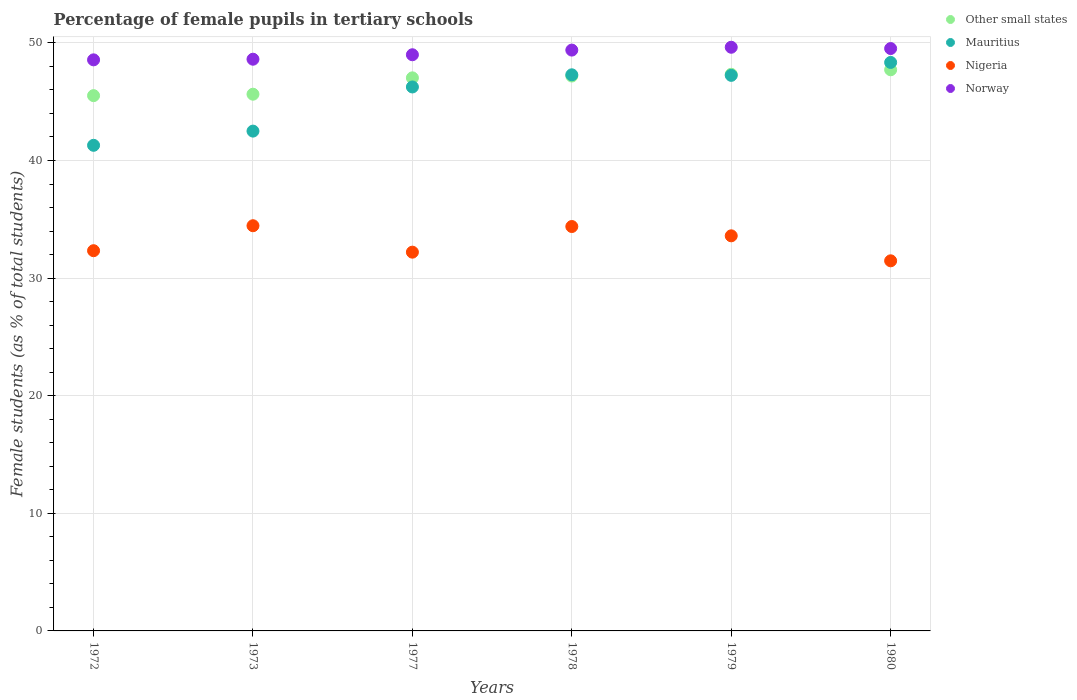What is the percentage of female pupils in tertiary schools in Other small states in 1973?
Make the answer very short. 45.64. Across all years, what is the maximum percentage of female pupils in tertiary schools in Other small states?
Your response must be concise. 47.71. Across all years, what is the minimum percentage of female pupils in tertiary schools in Other small states?
Your answer should be very brief. 45.52. In which year was the percentage of female pupils in tertiary schools in Norway minimum?
Give a very brief answer. 1972. What is the total percentage of female pupils in tertiary schools in Norway in the graph?
Offer a terse response. 294.7. What is the difference between the percentage of female pupils in tertiary schools in Norway in 1977 and that in 1979?
Your response must be concise. -0.64. What is the difference between the percentage of female pupils in tertiary schools in Mauritius in 1973 and the percentage of female pupils in tertiary schools in Other small states in 1980?
Your answer should be very brief. -5.22. What is the average percentage of female pupils in tertiary schools in Mauritius per year?
Your answer should be compact. 45.48. In the year 1972, what is the difference between the percentage of female pupils in tertiary schools in Other small states and percentage of female pupils in tertiary schools in Nigeria?
Make the answer very short. 13.19. What is the ratio of the percentage of female pupils in tertiary schools in Norway in 1973 to that in 1977?
Your response must be concise. 0.99. Is the percentage of female pupils in tertiary schools in Nigeria in 1977 less than that in 1978?
Offer a very short reply. Yes. Is the difference between the percentage of female pupils in tertiary schools in Other small states in 1973 and 1980 greater than the difference between the percentage of female pupils in tertiary schools in Nigeria in 1973 and 1980?
Your answer should be compact. No. What is the difference between the highest and the second highest percentage of female pupils in tertiary schools in Mauritius?
Your answer should be very brief. 1.05. What is the difference between the highest and the lowest percentage of female pupils in tertiary schools in Other small states?
Ensure brevity in your answer.  2.2. Is the sum of the percentage of female pupils in tertiary schools in Norway in 1972 and 1980 greater than the maximum percentage of female pupils in tertiary schools in Nigeria across all years?
Your answer should be compact. Yes. Does the percentage of female pupils in tertiary schools in Norway monotonically increase over the years?
Provide a succinct answer. No. How many years are there in the graph?
Your response must be concise. 6. Are the values on the major ticks of Y-axis written in scientific E-notation?
Keep it short and to the point. No. Does the graph contain any zero values?
Provide a succinct answer. No. Where does the legend appear in the graph?
Provide a succinct answer. Top right. How many legend labels are there?
Offer a very short reply. 4. What is the title of the graph?
Offer a terse response. Percentage of female pupils in tertiary schools. What is the label or title of the Y-axis?
Give a very brief answer. Female students (as % of total students). What is the Female students (as % of total students) of Other small states in 1972?
Give a very brief answer. 45.52. What is the Female students (as % of total students) of Mauritius in 1972?
Ensure brevity in your answer.  41.29. What is the Female students (as % of total students) in Nigeria in 1972?
Offer a terse response. 32.33. What is the Female students (as % of total students) of Norway in 1972?
Offer a terse response. 48.56. What is the Female students (as % of total students) in Other small states in 1973?
Your response must be concise. 45.64. What is the Female students (as % of total students) of Mauritius in 1973?
Ensure brevity in your answer.  42.5. What is the Female students (as % of total students) of Nigeria in 1973?
Your answer should be compact. 34.45. What is the Female students (as % of total students) in Norway in 1973?
Provide a short and direct response. 48.61. What is the Female students (as % of total students) of Other small states in 1977?
Offer a very short reply. 47.03. What is the Female students (as % of total students) in Mauritius in 1977?
Your answer should be compact. 46.25. What is the Female students (as % of total students) in Nigeria in 1977?
Your response must be concise. 32.21. What is the Female students (as % of total students) of Norway in 1977?
Offer a terse response. 48.99. What is the Female students (as % of total students) in Other small states in 1978?
Make the answer very short. 47.18. What is the Female students (as % of total students) in Mauritius in 1978?
Your answer should be compact. 47.29. What is the Female students (as % of total students) of Nigeria in 1978?
Offer a terse response. 34.39. What is the Female students (as % of total students) in Norway in 1978?
Your answer should be compact. 49.39. What is the Female students (as % of total students) in Other small states in 1979?
Offer a terse response. 47.33. What is the Female students (as % of total students) in Mauritius in 1979?
Make the answer very short. 47.24. What is the Female students (as % of total students) of Nigeria in 1979?
Your answer should be very brief. 33.6. What is the Female students (as % of total students) in Norway in 1979?
Offer a very short reply. 49.63. What is the Female students (as % of total students) of Other small states in 1980?
Offer a very short reply. 47.71. What is the Female students (as % of total students) of Mauritius in 1980?
Make the answer very short. 48.34. What is the Female students (as % of total students) of Nigeria in 1980?
Your response must be concise. 31.47. What is the Female students (as % of total students) in Norway in 1980?
Offer a very short reply. 49.52. Across all years, what is the maximum Female students (as % of total students) of Other small states?
Ensure brevity in your answer.  47.71. Across all years, what is the maximum Female students (as % of total students) of Mauritius?
Give a very brief answer. 48.34. Across all years, what is the maximum Female students (as % of total students) of Nigeria?
Keep it short and to the point. 34.45. Across all years, what is the maximum Female students (as % of total students) of Norway?
Keep it short and to the point. 49.63. Across all years, what is the minimum Female students (as % of total students) in Other small states?
Your answer should be compact. 45.52. Across all years, what is the minimum Female students (as % of total students) of Mauritius?
Make the answer very short. 41.29. Across all years, what is the minimum Female students (as % of total students) in Nigeria?
Give a very brief answer. 31.47. Across all years, what is the minimum Female students (as % of total students) of Norway?
Provide a succinct answer. 48.56. What is the total Female students (as % of total students) of Other small states in the graph?
Offer a terse response. 280.41. What is the total Female students (as % of total students) of Mauritius in the graph?
Your response must be concise. 272.91. What is the total Female students (as % of total students) in Nigeria in the graph?
Keep it short and to the point. 198.44. What is the total Female students (as % of total students) of Norway in the graph?
Provide a succinct answer. 294.7. What is the difference between the Female students (as % of total students) of Other small states in 1972 and that in 1973?
Offer a terse response. -0.12. What is the difference between the Female students (as % of total students) of Mauritius in 1972 and that in 1973?
Make the answer very short. -1.21. What is the difference between the Female students (as % of total students) in Nigeria in 1972 and that in 1973?
Give a very brief answer. -2.12. What is the difference between the Female students (as % of total students) of Norway in 1972 and that in 1973?
Provide a short and direct response. -0.05. What is the difference between the Female students (as % of total students) in Other small states in 1972 and that in 1977?
Offer a terse response. -1.51. What is the difference between the Female students (as % of total students) of Mauritius in 1972 and that in 1977?
Give a very brief answer. -4.96. What is the difference between the Female students (as % of total students) in Nigeria in 1972 and that in 1977?
Keep it short and to the point. 0.12. What is the difference between the Female students (as % of total students) of Norway in 1972 and that in 1977?
Provide a succinct answer. -0.43. What is the difference between the Female students (as % of total students) in Other small states in 1972 and that in 1978?
Your response must be concise. -1.67. What is the difference between the Female students (as % of total students) in Mauritius in 1972 and that in 1978?
Your answer should be very brief. -5.99. What is the difference between the Female students (as % of total students) of Nigeria in 1972 and that in 1978?
Your answer should be very brief. -2.06. What is the difference between the Female students (as % of total students) in Norway in 1972 and that in 1978?
Offer a very short reply. -0.83. What is the difference between the Female students (as % of total students) in Other small states in 1972 and that in 1979?
Offer a terse response. -1.81. What is the difference between the Female students (as % of total students) in Mauritius in 1972 and that in 1979?
Offer a terse response. -5.95. What is the difference between the Female students (as % of total students) in Nigeria in 1972 and that in 1979?
Your answer should be compact. -1.26. What is the difference between the Female students (as % of total students) in Norway in 1972 and that in 1979?
Make the answer very short. -1.07. What is the difference between the Female students (as % of total students) in Other small states in 1972 and that in 1980?
Give a very brief answer. -2.2. What is the difference between the Female students (as % of total students) in Mauritius in 1972 and that in 1980?
Make the answer very short. -7.05. What is the difference between the Female students (as % of total students) in Nigeria in 1972 and that in 1980?
Your answer should be compact. 0.86. What is the difference between the Female students (as % of total students) in Norway in 1972 and that in 1980?
Your answer should be very brief. -0.96. What is the difference between the Female students (as % of total students) in Other small states in 1973 and that in 1977?
Your answer should be very brief. -1.39. What is the difference between the Female students (as % of total students) in Mauritius in 1973 and that in 1977?
Your response must be concise. -3.75. What is the difference between the Female students (as % of total students) in Nigeria in 1973 and that in 1977?
Provide a short and direct response. 2.25. What is the difference between the Female students (as % of total students) of Norway in 1973 and that in 1977?
Make the answer very short. -0.38. What is the difference between the Female students (as % of total students) in Other small states in 1973 and that in 1978?
Provide a succinct answer. -1.54. What is the difference between the Female students (as % of total students) of Mauritius in 1973 and that in 1978?
Give a very brief answer. -4.79. What is the difference between the Female students (as % of total students) in Nigeria in 1973 and that in 1978?
Offer a very short reply. 0.07. What is the difference between the Female students (as % of total students) in Norway in 1973 and that in 1978?
Offer a terse response. -0.78. What is the difference between the Female students (as % of total students) of Other small states in 1973 and that in 1979?
Offer a very short reply. -1.69. What is the difference between the Female students (as % of total students) of Mauritius in 1973 and that in 1979?
Keep it short and to the point. -4.74. What is the difference between the Female students (as % of total students) in Nigeria in 1973 and that in 1979?
Your answer should be compact. 0.86. What is the difference between the Female students (as % of total students) in Norway in 1973 and that in 1979?
Provide a short and direct response. -1.02. What is the difference between the Female students (as % of total students) in Other small states in 1973 and that in 1980?
Your answer should be compact. -2.08. What is the difference between the Female students (as % of total students) in Mauritius in 1973 and that in 1980?
Offer a terse response. -5.84. What is the difference between the Female students (as % of total students) in Nigeria in 1973 and that in 1980?
Keep it short and to the point. 2.98. What is the difference between the Female students (as % of total students) of Norway in 1973 and that in 1980?
Offer a terse response. -0.91. What is the difference between the Female students (as % of total students) in Other small states in 1977 and that in 1978?
Provide a succinct answer. -0.15. What is the difference between the Female students (as % of total students) in Mauritius in 1977 and that in 1978?
Your response must be concise. -1.03. What is the difference between the Female students (as % of total students) of Nigeria in 1977 and that in 1978?
Provide a succinct answer. -2.18. What is the difference between the Female students (as % of total students) of Norway in 1977 and that in 1978?
Provide a succinct answer. -0.4. What is the difference between the Female students (as % of total students) of Other small states in 1977 and that in 1979?
Your response must be concise. -0.3. What is the difference between the Female students (as % of total students) in Mauritius in 1977 and that in 1979?
Provide a succinct answer. -0.99. What is the difference between the Female students (as % of total students) of Nigeria in 1977 and that in 1979?
Make the answer very short. -1.39. What is the difference between the Female students (as % of total students) of Norway in 1977 and that in 1979?
Keep it short and to the point. -0.64. What is the difference between the Female students (as % of total students) of Other small states in 1977 and that in 1980?
Offer a terse response. -0.69. What is the difference between the Female students (as % of total students) in Mauritius in 1977 and that in 1980?
Provide a short and direct response. -2.09. What is the difference between the Female students (as % of total students) in Nigeria in 1977 and that in 1980?
Ensure brevity in your answer.  0.74. What is the difference between the Female students (as % of total students) of Norway in 1977 and that in 1980?
Provide a short and direct response. -0.53. What is the difference between the Female students (as % of total students) of Other small states in 1978 and that in 1979?
Make the answer very short. -0.15. What is the difference between the Female students (as % of total students) in Mauritius in 1978 and that in 1979?
Your response must be concise. 0.05. What is the difference between the Female students (as % of total students) of Nigeria in 1978 and that in 1979?
Give a very brief answer. 0.79. What is the difference between the Female students (as % of total students) in Norway in 1978 and that in 1979?
Offer a terse response. -0.24. What is the difference between the Female students (as % of total students) of Other small states in 1978 and that in 1980?
Your response must be concise. -0.53. What is the difference between the Female students (as % of total students) in Mauritius in 1978 and that in 1980?
Make the answer very short. -1.05. What is the difference between the Female students (as % of total students) of Nigeria in 1978 and that in 1980?
Ensure brevity in your answer.  2.92. What is the difference between the Female students (as % of total students) in Norway in 1978 and that in 1980?
Provide a short and direct response. -0.13. What is the difference between the Female students (as % of total students) of Other small states in 1979 and that in 1980?
Give a very brief answer. -0.38. What is the difference between the Female students (as % of total students) of Mauritius in 1979 and that in 1980?
Make the answer very short. -1.1. What is the difference between the Female students (as % of total students) in Nigeria in 1979 and that in 1980?
Give a very brief answer. 2.12. What is the difference between the Female students (as % of total students) of Norway in 1979 and that in 1980?
Ensure brevity in your answer.  0.11. What is the difference between the Female students (as % of total students) in Other small states in 1972 and the Female students (as % of total students) in Mauritius in 1973?
Your response must be concise. 3.02. What is the difference between the Female students (as % of total students) of Other small states in 1972 and the Female students (as % of total students) of Nigeria in 1973?
Your answer should be very brief. 11.06. What is the difference between the Female students (as % of total students) of Other small states in 1972 and the Female students (as % of total students) of Norway in 1973?
Your response must be concise. -3.1. What is the difference between the Female students (as % of total students) in Mauritius in 1972 and the Female students (as % of total students) in Nigeria in 1973?
Offer a terse response. 6.84. What is the difference between the Female students (as % of total students) in Mauritius in 1972 and the Female students (as % of total students) in Norway in 1973?
Your answer should be compact. -7.32. What is the difference between the Female students (as % of total students) of Nigeria in 1972 and the Female students (as % of total students) of Norway in 1973?
Provide a succinct answer. -16.28. What is the difference between the Female students (as % of total students) in Other small states in 1972 and the Female students (as % of total students) in Mauritius in 1977?
Provide a succinct answer. -0.74. What is the difference between the Female students (as % of total students) in Other small states in 1972 and the Female students (as % of total students) in Nigeria in 1977?
Give a very brief answer. 13.31. What is the difference between the Female students (as % of total students) in Other small states in 1972 and the Female students (as % of total students) in Norway in 1977?
Provide a short and direct response. -3.48. What is the difference between the Female students (as % of total students) in Mauritius in 1972 and the Female students (as % of total students) in Nigeria in 1977?
Make the answer very short. 9.09. What is the difference between the Female students (as % of total students) in Mauritius in 1972 and the Female students (as % of total students) in Norway in 1977?
Offer a very short reply. -7.7. What is the difference between the Female students (as % of total students) in Nigeria in 1972 and the Female students (as % of total students) in Norway in 1977?
Offer a very short reply. -16.66. What is the difference between the Female students (as % of total students) of Other small states in 1972 and the Female students (as % of total students) of Mauritius in 1978?
Provide a short and direct response. -1.77. What is the difference between the Female students (as % of total students) in Other small states in 1972 and the Female students (as % of total students) in Nigeria in 1978?
Keep it short and to the point. 11.13. What is the difference between the Female students (as % of total students) of Other small states in 1972 and the Female students (as % of total students) of Norway in 1978?
Offer a terse response. -3.87. What is the difference between the Female students (as % of total students) of Mauritius in 1972 and the Female students (as % of total students) of Nigeria in 1978?
Provide a short and direct response. 6.91. What is the difference between the Female students (as % of total students) of Mauritius in 1972 and the Female students (as % of total students) of Norway in 1978?
Make the answer very short. -8.1. What is the difference between the Female students (as % of total students) in Nigeria in 1972 and the Female students (as % of total students) in Norway in 1978?
Ensure brevity in your answer.  -17.06. What is the difference between the Female students (as % of total students) of Other small states in 1972 and the Female students (as % of total students) of Mauritius in 1979?
Give a very brief answer. -1.72. What is the difference between the Female students (as % of total students) in Other small states in 1972 and the Female students (as % of total students) in Nigeria in 1979?
Offer a terse response. 11.92. What is the difference between the Female students (as % of total students) of Other small states in 1972 and the Female students (as % of total students) of Norway in 1979?
Your response must be concise. -4.11. What is the difference between the Female students (as % of total students) of Mauritius in 1972 and the Female students (as % of total students) of Nigeria in 1979?
Make the answer very short. 7.7. What is the difference between the Female students (as % of total students) in Mauritius in 1972 and the Female students (as % of total students) in Norway in 1979?
Provide a short and direct response. -8.34. What is the difference between the Female students (as % of total students) of Nigeria in 1972 and the Female students (as % of total students) of Norway in 1979?
Keep it short and to the point. -17.3. What is the difference between the Female students (as % of total students) in Other small states in 1972 and the Female students (as % of total students) in Mauritius in 1980?
Your answer should be very brief. -2.82. What is the difference between the Female students (as % of total students) in Other small states in 1972 and the Female students (as % of total students) in Nigeria in 1980?
Provide a succinct answer. 14.04. What is the difference between the Female students (as % of total students) of Other small states in 1972 and the Female students (as % of total students) of Norway in 1980?
Provide a short and direct response. -4. What is the difference between the Female students (as % of total students) of Mauritius in 1972 and the Female students (as % of total students) of Nigeria in 1980?
Your answer should be very brief. 9.82. What is the difference between the Female students (as % of total students) of Mauritius in 1972 and the Female students (as % of total students) of Norway in 1980?
Your response must be concise. -8.23. What is the difference between the Female students (as % of total students) of Nigeria in 1972 and the Female students (as % of total students) of Norway in 1980?
Offer a very short reply. -17.19. What is the difference between the Female students (as % of total students) of Other small states in 1973 and the Female students (as % of total students) of Mauritius in 1977?
Your answer should be very brief. -0.62. What is the difference between the Female students (as % of total students) of Other small states in 1973 and the Female students (as % of total students) of Nigeria in 1977?
Your response must be concise. 13.43. What is the difference between the Female students (as % of total students) in Other small states in 1973 and the Female students (as % of total students) in Norway in 1977?
Keep it short and to the point. -3.35. What is the difference between the Female students (as % of total students) of Mauritius in 1973 and the Female students (as % of total students) of Nigeria in 1977?
Offer a terse response. 10.29. What is the difference between the Female students (as % of total students) in Mauritius in 1973 and the Female students (as % of total students) in Norway in 1977?
Give a very brief answer. -6.49. What is the difference between the Female students (as % of total students) in Nigeria in 1973 and the Female students (as % of total students) in Norway in 1977?
Provide a short and direct response. -14.54. What is the difference between the Female students (as % of total students) of Other small states in 1973 and the Female students (as % of total students) of Mauritius in 1978?
Make the answer very short. -1.65. What is the difference between the Female students (as % of total students) in Other small states in 1973 and the Female students (as % of total students) in Nigeria in 1978?
Make the answer very short. 11.25. What is the difference between the Female students (as % of total students) of Other small states in 1973 and the Female students (as % of total students) of Norway in 1978?
Your answer should be very brief. -3.75. What is the difference between the Female students (as % of total students) of Mauritius in 1973 and the Female students (as % of total students) of Nigeria in 1978?
Your answer should be compact. 8.11. What is the difference between the Female students (as % of total students) of Mauritius in 1973 and the Female students (as % of total students) of Norway in 1978?
Offer a very short reply. -6.89. What is the difference between the Female students (as % of total students) of Nigeria in 1973 and the Female students (as % of total students) of Norway in 1978?
Your answer should be very brief. -14.93. What is the difference between the Female students (as % of total students) of Other small states in 1973 and the Female students (as % of total students) of Mauritius in 1979?
Offer a terse response. -1.6. What is the difference between the Female students (as % of total students) of Other small states in 1973 and the Female students (as % of total students) of Nigeria in 1979?
Provide a succinct answer. 12.04. What is the difference between the Female students (as % of total students) of Other small states in 1973 and the Female students (as % of total students) of Norway in 1979?
Provide a short and direct response. -3.99. What is the difference between the Female students (as % of total students) in Mauritius in 1973 and the Female students (as % of total students) in Nigeria in 1979?
Your answer should be very brief. 8.9. What is the difference between the Female students (as % of total students) in Mauritius in 1973 and the Female students (as % of total students) in Norway in 1979?
Give a very brief answer. -7.13. What is the difference between the Female students (as % of total students) in Nigeria in 1973 and the Female students (as % of total students) in Norway in 1979?
Your response must be concise. -15.18. What is the difference between the Female students (as % of total students) of Other small states in 1973 and the Female students (as % of total students) of Mauritius in 1980?
Provide a short and direct response. -2.7. What is the difference between the Female students (as % of total students) in Other small states in 1973 and the Female students (as % of total students) in Nigeria in 1980?
Give a very brief answer. 14.17. What is the difference between the Female students (as % of total students) of Other small states in 1973 and the Female students (as % of total students) of Norway in 1980?
Provide a succinct answer. -3.88. What is the difference between the Female students (as % of total students) in Mauritius in 1973 and the Female students (as % of total students) in Nigeria in 1980?
Offer a very short reply. 11.03. What is the difference between the Female students (as % of total students) in Mauritius in 1973 and the Female students (as % of total students) in Norway in 1980?
Your answer should be compact. -7.02. What is the difference between the Female students (as % of total students) in Nigeria in 1973 and the Female students (as % of total students) in Norway in 1980?
Your response must be concise. -15.07. What is the difference between the Female students (as % of total students) of Other small states in 1977 and the Female students (as % of total students) of Mauritius in 1978?
Make the answer very short. -0.26. What is the difference between the Female students (as % of total students) in Other small states in 1977 and the Female students (as % of total students) in Nigeria in 1978?
Make the answer very short. 12.64. What is the difference between the Female students (as % of total students) in Other small states in 1977 and the Female students (as % of total students) in Norway in 1978?
Keep it short and to the point. -2.36. What is the difference between the Female students (as % of total students) in Mauritius in 1977 and the Female students (as % of total students) in Nigeria in 1978?
Provide a short and direct response. 11.87. What is the difference between the Female students (as % of total students) of Mauritius in 1977 and the Female students (as % of total students) of Norway in 1978?
Give a very brief answer. -3.14. What is the difference between the Female students (as % of total students) of Nigeria in 1977 and the Female students (as % of total students) of Norway in 1978?
Your answer should be very brief. -17.18. What is the difference between the Female students (as % of total students) in Other small states in 1977 and the Female students (as % of total students) in Mauritius in 1979?
Your answer should be very brief. -0.21. What is the difference between the Female students (as % of total students) of Other small states in 1977 and the Female students (as % of total students) of Nigeria in 1979?
Give a very brief answer. 13.43. What is the difference between the Female students (as % of total students) of Other small states in 1977 and the Female students (as % of total students) of Norway in 1979?
Give a very brief answer. -2.6. What is the difference between the Female students (as % of total students) in Mauritius in 1977 and the Female students (as % of total students) in Nigeria in 1979?
Keep it short and to the point. 12.66. What is the difference between the Female students (as % of total students) of Mauritius in 1977 and the Female students (as % of total students) of Norway in 1979?
Your response must be concise. -3.38. What is the difference between the Female students (as % of total students) of Nigeria in 1977 and the Female students (as % of total students) of Norway in 1979?
Offer a terse response. -17.42. What is the difference between the Female students (as % of total students) of Other small states in 1977 and the Female students (as % of total students) of Mauritius in 1980?
Make the answer very short. -1.31. What is the difference between the Female students (as % of total students) of Other small states in 1977 and the Female students (as % of total students) of Nigeria in 1980?
Make the answer very short. 15.56. What is the difference between the Female students (as % of total students) of Other small states in 1977 and the Female students (as % of total students) of Norway in 1980?
Give a very brief answer. -2.49. What is the difference between the Female students (as % of total students) in Mauritius in 1977 and the Female students (as % of total students) in Nigeria in 1980?
Your answer should be very brief. 14.78. What is the difference between the Female students (as % of total students) of Mauritius in 1977 and the Female students (as % of total students) of Norway in 1980?
Make the answer very short. -3.27. What is the difference between the Female students (as % of total students) in Nigeria in 1977 and the Female students (as % of total students) in Norway in 1980?
Keep it short and to the point. -17.31. What is the difference between the Female students (as % of total students) in Other small states in 1978 and the Female students (as % of total students) in Mauritius in 1979?
Your response must be concise. -0.06. What is the difference between the Female students (as % of total students) of Other small states in 1978 and the Female students (as % of total students) of Nigeria in 1979?
Provide a short and direct response. 13.59. What is the difference between the Female students (as % of total students) of Other small states in 1978 and the Female students (as % of total students) of Norway in 1979?
Make the answer very short. -2.45. What is the difference between the Female students (as % of total students) in Mauritius in 1978 and the Female students (as % of total students) in Nigeria in 1979?
Provide a succinct answer. 13.69. What is the difference between the Female students (as % of total students) of Mauritius in 1978 and the Female students (as % of total students) of Norway in 1979?
Provide a short and direct response. -2.34. What is the difference between the Female students (as % of total students) in Nigeria in 1978 and the Female students (as % of total students) in Norway in 1979?
Offer a terse response. -15.24. What is the difference between the Female students (as % of total students) of Other small states in 1978 and the Female students (as % of total students) of Mauritius in 1980?
Keep it short and to the point. -1.16. What is the difference between the Female students (as % of total students) in Other small states in 1978 and the Female students (as % of total students) in Nigeria in 1980?
Give a very brief answer. 15.71. What is the difference between the Female students (as % of total students) of Other small states in 1978 and the Female students (as % of total students) of Norway in 1980?
Keep it short and to the point. -2.34. What is the difference between the Female students (as % of total students) of Mauritius in 1978 and the Female students (as % of total students) of Nigeria in 1980?
Make the answer very short. 15.82. What is the difference between the Female students (as % of total students) in Mauritius in 1978 and the Female students (as % of total students) in Norway in 1980?
Your response must be concise. -2.23. What is the difference between the Female students (as % of total students) in Nigeria in 1978 and the Female students (as % of total students) in Norway in 1980?
Keep it short and to the point. -15.13. What is the difference between the Female students (as % of total students) of Other small states in 1979 and the Female students (as % of total students) of Mauritius in 1980?
Provide a succinct answer. -1.01. What is the difference between the Female students (as % of total students) in Other small states in 1979 and the Female students (as % of total students) in Nigeria in 1980?
Keep it short and to the point. 15.86. What is the difference between the Female students (as % of total students) of Other small states in 1979 and the Female students (as % of total students) of Norway in 1980?
Your response must be concise. -2.19. What is the difference between the Female students (as % of total students) of Mauritius in 1979 and the Female students (as % of total students) of Nigeria in 1980?
Your answer should be compact. 15.77. What is the difference between the Female students (as % of total students) in Mauritius in 1979 and the Female students (as % of total students) in Norway in 1980?
Offer a very short reply. -2.28. What is the difference between the Female students (as % of total students) of Nigeria in 1979 and the Female students (as % of total students) of Norway in 1980?
Offer a terse response. -15.92. What is the average Female students (as % of total students) of Other small states per year?
Give a very brief answer. 46.73. What is the average Female students (as % of total students) of Mauritius per year?
Offer a terse response. 45.48. What is the average Female students (as % of total students) of Nigeria per year?
Provide a succinct answer. 33.07. What is the average Female students (as % of total students) in Norway per year?
Provide a succinct answer. 49.12. In the year 1972, what is the difference between the Female students (as % of total students) in Other small states and Female students (as % of total students) in Mauritius?
Keep it short and to the point. 4.22. In the year 1972, what is the difference between the Female students (as % of total students) in Other small states and Female students (as % of total students) in Nigeria?
Your answer should be compact. 13.19. In the year 1972, what is the difference between the Female students (as % of total students) of Other small states and Female students (as % of total students) of Norway?
Keep it short and to the point. -3.04. In the year 1972, what is the difference between the Female students (as % of total students) of Mauritius and Female students (as % of total students) of Nigeria?
Make the answer very short. 8.96. In the year 1972, what is the difference between the Female students (as % of total students) of Mauritius and Female students (as % of total students) of Norway?
Offer a terse response. -7.27. In the year 1972, what is the difference between the Female students (as % of total students) in Nigeria and Female students (as % of total students) in Norway?
Keep it short and to the point. -16.23. In the year 1973, what is the difference between the Female students (as % of total students) of Other small states and Female students (as % of total students) of Mauritius?
Give a very brief answer. 3.14. In the year 1973, what is the difference between the Female students (as % of total students) in Other small states and Female students (as % of total students) in Nigeria?
Offer a terse response. 11.18. In the year 1973, what is the difference between the Female students (as % of total students) in Other small states and Female students (as % of total students) in Norway?
Your answer should be compact. -2.98. In the year 1973, what is the difference between the Female students (as % of total students) of Mauritius and Female students (as % of total students) of Nigeria?
Keep it short and to the point. 8.05. In the year 1973, what is the difference between the Female students (as % of total students) of Mauritius and Female students (as % of total students) of Norway?
Give a very brief answer. -6.11. In the year 1973, what is the difference between the Female students (as % of total students) of Nigeria and Female students (as % of total students) of Norway?
Provide a short and direct response. -14.16. In the year 1977, what is the difference between the Female students (as % of total students) in Other small states and Female students (as % of total students) in Mauritius?
Ensure brevity in your answer.  0.78. In the year 1977, what is the difference between the Female students (as % of total students) of Other small states and Female students (as % of total students) of Nigeria?
Your answer should be very brief. 14.82. In the year 1977, what is the difference between the Female students (as % of total students) in Other small states and Female students (as % of total students) in Norway?
Offer a very short reply. -1.96. In the year 1977, what is the difference between the Female students (as % of total students) of Mauritius and Female students (as % of total students) of Nigeria?
Offer a very short reply. 14.05. In the year 1977, what is the difference between the Female students (as % of total students) of Mauritius and Female students (as % of total students) of Norway?
Give a very brief answer. -2.74. In the year 1977, what is the difference between the Female students (as % of total students) in Nigeria and Female students (as % of total students) in Norway?
Your answer should be compact. -16.79. In the year 1978, what is the difference between the Female students (as % of total students) in Other small states and Female students (as % of total students) in Mauritius?
Provide a short and direct response. -0.1. In the year 1978, what is the difference between the Female students (as % of total students) of Other small states and Female students (as % of total students) of Nigeria?
Offer a very short reply. 12.8. In the year 1978, what is the difference between the Female students (as % of total students) of Other small states and Female students (as % of total students) of Norway?
Your answer should be very brief. -2.21. In the year 1978, what is the difference between the Female students (as % of total students) in Mauritius and Female students (as % of total students) in Norway?
Make the answer very short. -2.1. In the year 1978, what is the difference between the Female students (as % of total students) of Nigeria and Female students (as % of total students) of Norway?
Offer a terse response. -15. In the year 1979, what is the difference between the Female students (as % of total students) in Other small states and Female students (as % of total students) in Mauritius?
Offer a very short reply. 0.09. In the year 1979, what is the difference between the Female students (as % of total students) of Other small states and Female students (as % of total students) of Nigeria?
Your response must be concise. 13.74. In the year 1979, what is the difference between the Female students (as % of total students) of Other small states and Female students (as % of total students) of Norway?
Your response must be concise. -2.3. In the year 1979, what is the difference between the Female students (as % of total students) of Mauritius and Female students (as % of total students) of Nigeria?
Provide a succinct answer. 13.64. In the year 1979, what is the difference between the Female students (as % of total students) of Mauritius and Female students (as % of total students) of Norway?
Your answer should be compact. -2.39. In the year 1979, what is the difference between the Female students (as % of total students) of Nigeria and Female students (as % of total students) of Norway?
Your answer should be very brief. -16.03. In the year 1980, what is the difference between the Female students (as % of total students) in Other small states and Female students (as % of total students) in Mauritius?
Give a very brief answer. -0.62. In the year 1980, what is the difference between the Female students (as % of total students) of Other small states and Female students (as % of total students) of Nigeria?
Offer a terse response. 16.24. In the year 1980, what is the difference between the Female students (as % of total students) of Other small states and Female students (as % of total students) of Norway?
Your answer should be very brief. -1.8. In the year 1980, what is the difference between the Female students (as % of total students) of Mauritius and Female students (as % of total students) of Nigeria?
Your answer should be compact. 16.87. In the year 1980, what is the difference between the Female students (as % of total students) of Mauritius and Female students (as % of total students) of Norway?
Give a very brief answer. -1.18. In the year 1980, what is the difference between the Female students (as % of total students) in Nigeria and Female students (as % of total students) in Norway?
Offer a very short reply. -18.05. What is the ratio of the Female students (as % of total students) of Other small states in 1972 to that in 1973?
Your response must be concise. 1. What is the ratio of the Female students (as % of total students) of Mauritius in 1972 to that in 1973?
Your answer should be very brief. 0.97. What is the ratio of the Female students (as % of total students) in Nigeria in 1972 to that in 1973?
Provide a succinct answer. 0.94. What is the ratio of the Female students (as % of total students) in Norway in 1972 to that in 1973?
Your response must be concise. 1. What is the ratio of the Female students (as % of total students) in Other small states in 1972 to that in 1977?
Ensure brevity in your answer.  0.97. What is the ratio of the Female students (as % of total students) in Mauritius in 1972 to that in 1977?
Give a very brief answer. 0.89. What is the ratio of the Female students (as % of total students) of Other small states in 1972 to that in 1978?
Keep it short and to the point. 0.96. What is the ratio of the Female students (as % of total students) in Mauritius in 1972 to that in 1978?
Your answer should be compact. 0.87. What is the ratio of the Female students (as % of total students) in Nigeria in 1972 to that in 1978?
Provide a succinct answer. 0.94. What is the ratio of the Female students (as % of total students) in Norway in 1972 to that in 1978?
Your answer should be very brief. 0.98. What is the ratio of the Female students (as % of total students) in Other small states in 1972 to that in 1979?
Make the answer very short. 0.96. What is the ratio of the Female students (as % of total students) of Mauritius in 1972 to that in 1979?
Your response must be concise. 0.87. What is the ratio of the Female students (as % of total students) of Nigeria in 1972 to that in 1979?
Provide a succinct answer. 0.96. What is the ratio of the Female students (as % of total students) in Norway in 1972 to that in 1979?
Ensure brevity in your answer.  0.98. What is the ratio of the Female students (as % of total students) in Other small states in 1972 to that in 1980?
Offer a terse response. 0.95. What is the ratio of the Female students (as % of total students) of Mauritius in 1972 to that in 1980?
Provide a succinct answer. 0.85. What is the ratio of the Female students (as % of total students) of Nigeria in 1972 to that in 1980?
Keep it short and to the point. 1.03. What is the ratio of the Female students (as % of total students) of Norway in 1972 to that in 1980?
Ensure brevity in your answer.  0.98. What is the ratio of the Female students (as % of total students) in Other small states in 1973 to that in 1977?
Make the answer very short. 0.97. What is the ratio of the Female students (as % of total students) in Mauritius in 1973 to that in 1977?
Your answer should be compact. 0.92. What is the ratio of the Female students (as % of total students) in Nigeria in 1973 to that in 1977?
Ensure brevity in your answer.  1.07. What is the ratio of the Female students (as % of total students) in Norway in 1973 to that in 1977?
Provide a short and direct response. 0.99. What is the ratio of the Female students (as % of total students) of Other small states in 1973 to that in 1978?
Ensure brevity in your answer.  0.97. What is the ratio of the Female students (as % of total students) of Mauritius in 1973 to that in 1978?
Ensure brevity in your answer.  0.9. What is the ratio of the Female students (as % of total students) in Nigeria in 1973 to that in 1978?
Give a very brief answer. 1. What is the ratio of the Female students (as % of total students) of Norway in 1973 to that in 1978?
Provide a succinct answer. 0.98. What is the ratio of the Female students (as % of total students) of Other small states in 1973 to that in 1979?
Make the answer very short. 0.96. What is the ratio of the Female students (as % of total students) in Mauritius in 1973 to that in 1979?
Provide a succinct answer. 0.9. What is the ratio of the Female students (as % of total students) of Nigeria in 1973 to that in 1979?
Make the answer very short. 1.03. What is the ratio of the Female students (as % of total students) of Norway in 1973 to that in 1979?
Offer a very short reply. 0.98. What is the ratio of the Female students (as % of total students) of Other small states in 1973 to that in 1980?
Your answer should be very brief. 0.96. What is the ratio of the Female students (as % of total students) in Mauritius in 1973 to that in 1980?
Make the answer very short. 0.88. What is the ratio of the Female students (as % of total students) in Nigeria in 1973 to that in 1980?
Make the answer very short. 1.09. What is the ratio of the Female students (as % of total students) of Norway in 1973 to that in 1980?
Make the answer very short. 0.98. What is the ratio of the Female students (as % of total students) in Other small states in 1977 to that in 1978?
Your response must be concise. 1. What is the ratio of the Female students (as % of total students) in Mauritius in 1977 to that in 1978?
Provide a short and direct response. 0.98. What is the ratio of the Female students (as % of total students) of Nigeria in 1977 to that in 1978?
Provide a short and direct response. 0.94. What is the ratio of the Female students (as % of total students) of Norway in 1977 to that in 1978?
Offer a very short reply. 0.99. What is the ratio of the Female students (as % of total students) of Mauritius in 1977 to that in 1979?
Your response must be concise. 0.98. What is the ratio of the Female students (as % of total students) in Nigeria in 1977 to that in 1979?
Offer a very short reply. 0.96. What is the ratio of the Female students (as % of total students) of Norway in 1977 to that in 1979?
Ensure brevity in your answer.  0.99. What is the ratio of the Female students (as % of total students) in Other small states in 1977 to that in 1980?
Offer a terse response. 0.99. What is the ratio of the Female students (as % of total students) in Mauritius in 1977 to that in 1980?
Your response must be concise. 0.96. What is the ratio of the Female students (as % of total students) of Nigeria in 1977 to that in 1980?
Offer a terse response. 1.02. What is the ratio of the Female students (as % of total students) of Norway in 1977 to that in 1980?
Offer a very short reply. 0.99. What is the ratio of the Female students (as % of total students) in Mauritius in 1978 to that in 1979?
Provide a succinct answer. 1. What is the ratio of the Female students (as % of total students) in Nigeria in 1978 to that in 1979?
Give a very brief answer. 1.02. What is the ratio of the Female students (as % of total students) in Norway in 1978 to that in 1979?
Offer a very short reply. 1. What is the ratio of the Female students (as % of total students) of Other small states in 1978 to that in 1980?
Your answer should be compact. 0.99. What is the ratio of the Female students (as % of total students) of Mauritius in 1978 to that in 1980?
Offer a terse response. 0.98. What is the ratio of the Female students (as % of total students) of Nigeria in 1978 to that in 1980?
Offer a very short reply. 1.09. What is the ratio of the Female students (as % of total students) in Mauritius in 1979 to that in 1980?
Ensure brevity in your answer.  0.98. What is the ratio of the Female students (as % of total students) in Nigeria in 1979 to that in 1980?
Your answer should be compact. 1.07. What is the ratio of the Female students (as % of total students) in Norway in 1979 to that in 1980?
Provide a short and direct response. 1. What is the difference between the highest and the second highest Female students (as % of total students) in Other small states?
Your answer should be very brief. 0.38. What is the difference between the highest and the second highest Female students (as % of total students) of Mauritius?
Your answer should be compact. 1.05. What is the difference between the highest and the second highest Female students (as % of total students) in Nigeria?
Ensure brevity in your answer.  0.07. What is the difference between the highest and the second highest Female students (as % of total students) in Norway?
Ensure brevity in your answer.  0.11. What is the difference between the highest and the lowest Female students (as % of total students) in Other small states?
Make the answer very short. 2.2. What is the difference between the highest and the lowest Female students (as % of total students) of Mauritius?
Make the answer very short. 7.05. What is the difference between the highest and the lowest Female students (as % of total students) of Nigeria?
Give a very brief answer. 2.98. What is the difference between the highest and the lowest Female students (as % of total students) of Norway?
Ensure brevity in your answer.  1.07. 